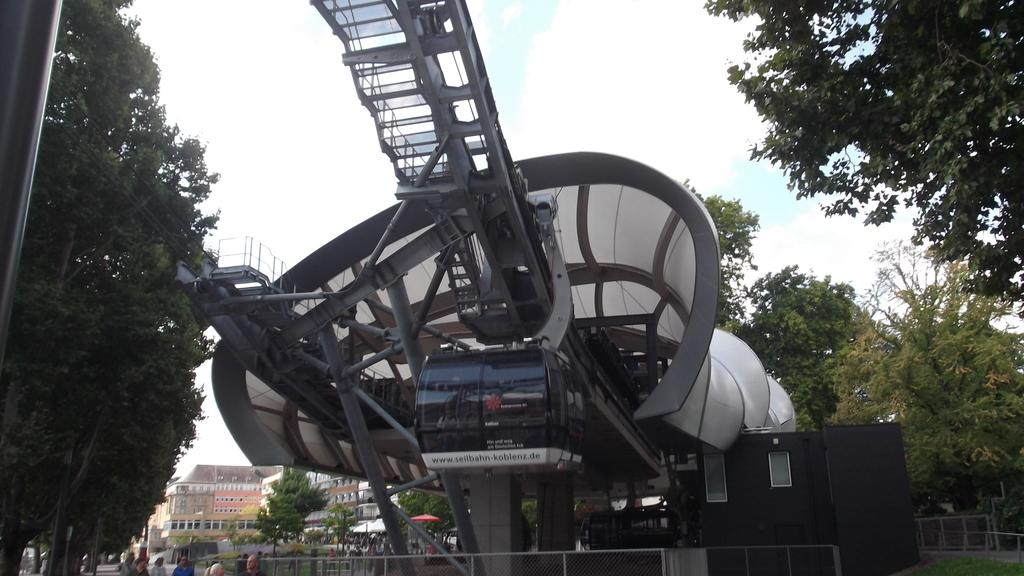What type of natural elements can be seen in the image? There are trees in the image. What man-made structures are present in the image? There are poles, fencing, buildings, and a cable-car in the image. Are there any people visible in the image? Yes, there are people in the image. What architectural features can be seen on the buildings? There are windows visible on the buildings. What mode of transportation is featured in the image? There is a cable-car in the image. What part of the natural environment is visible in the image? The sky is visible in the image. Can you describe the patch of rainstorm in the image? There is no rainstorm present in the image; the sky is visible, but no rainstorm is depicted. What type of bird can be seen perched on the cable-car in the image? There are no birds visible in the image, including robins. 